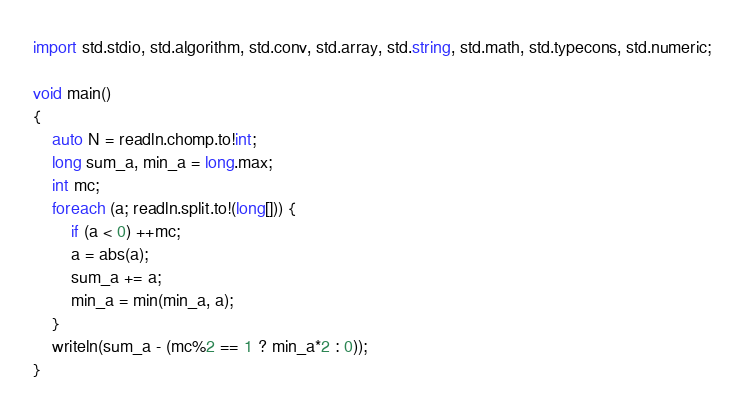Convert code to text. <code><loc_0><loc_0><loc_500><loc_500><_D_>import std.stdio, std.algorithm, std.conv, std.array, std.string, std.math, std.typecons, std.numeric;

void main()
{
    auto N = readln.chomp.to!int;
    long sum_a, min_a = long.max;
    int mc;
    foreach (a; readln.split.to!(long[])) {
        if (a < 0) ++mc;
        a = abs(a);
        sum_a += a;
        min_a = min(min_a, a);
    }
    writeln(sum_a - (mc%2 == 1 ? min_a*2 : 0));
}</code> 